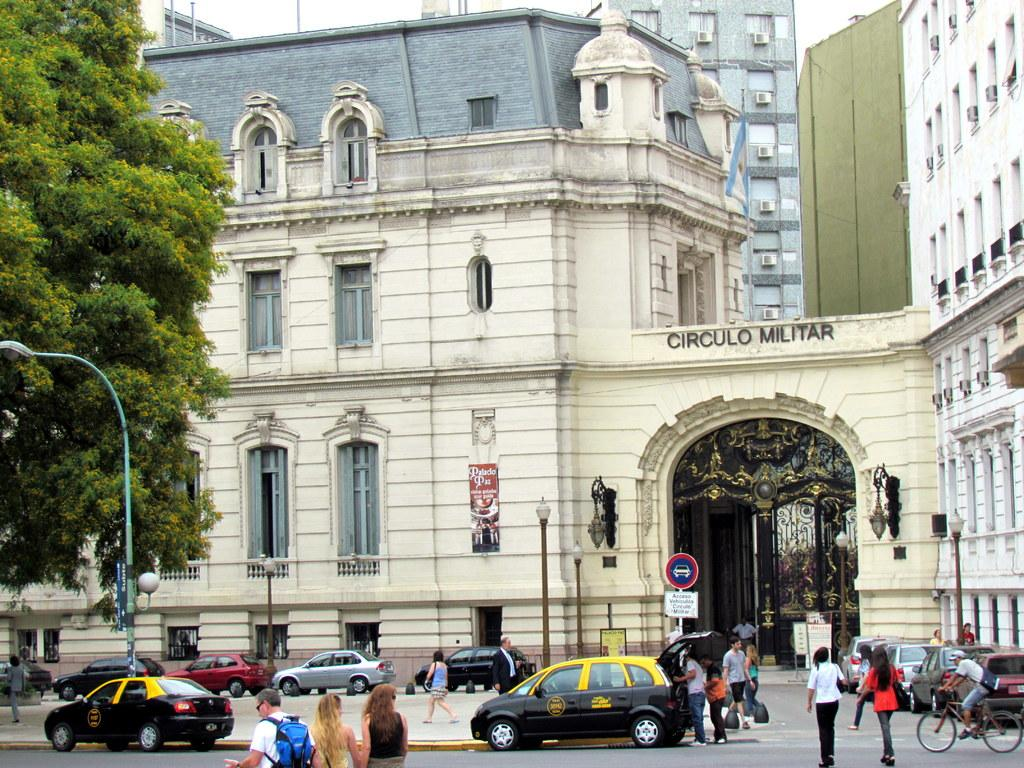Provide a one-sentence caption for the provided image. a street scene of an old building named Circulo Militar. 